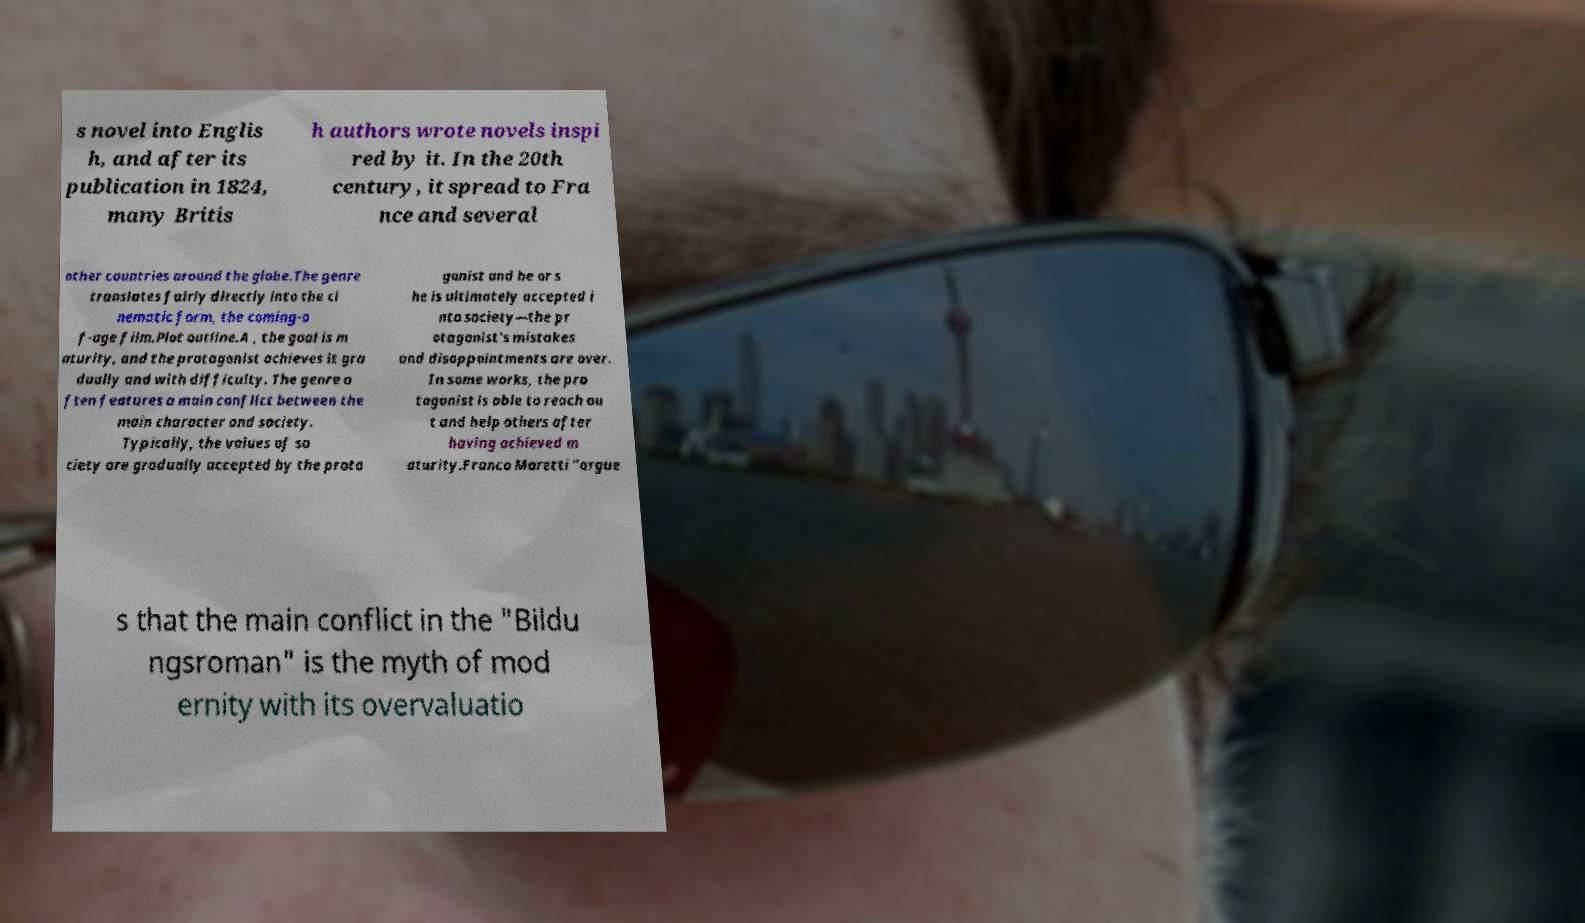Please identify and transcribe the text found in this image. s novel into Englis h, and after its publication in 1824, many Britis h authors wrote novels inspi red by it. In the 20th century, it spread to Fra nce and several other countries around the globe.The genre translates fairly directly into the ci nematic form, the coming-o f-age film.Plot outline.A , the goal is m aturity, and the protagonist achieves it gra dually and with difficulty. The genre o ften features a main conflict between the main character and society. Typically, the values of so ciety are gradually accepted by the prota gonist and he or s he is ultimately accepted i nto society—the pr otagonist's mistakes and disappointments are over. In some works, the pro tagonist is able to reach ou t and help others after having achieved m aturity.Franco Moretti "argue s that the main conflict in the "Bildu ngsroman" is the myth of mod ernity with its overvaluatio 